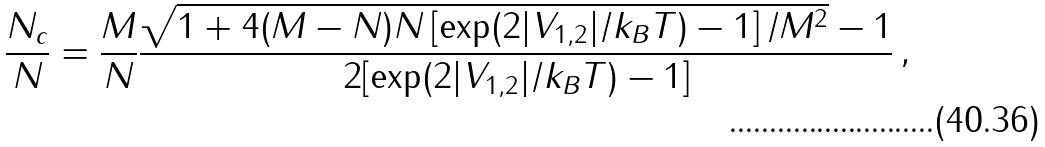Convert formula to latex. <formula><loc_0><loc_0><loc_500><loc_500>\frac { N _ { c } } { N } = \frac { M } { N } \frac { \sqrt { 1 + 4 ( M - N ) N \left [ \exp ( 2 | V _ { 1 , 2 } | / k _ { B } T ) - 1 \right ] / M ^ { 2 } } - 1 } { 2 [ \exp ( 2 | V _ { 1 , 2 } | / k _ { B } T ) - 1 ] } \, ,</formula> 